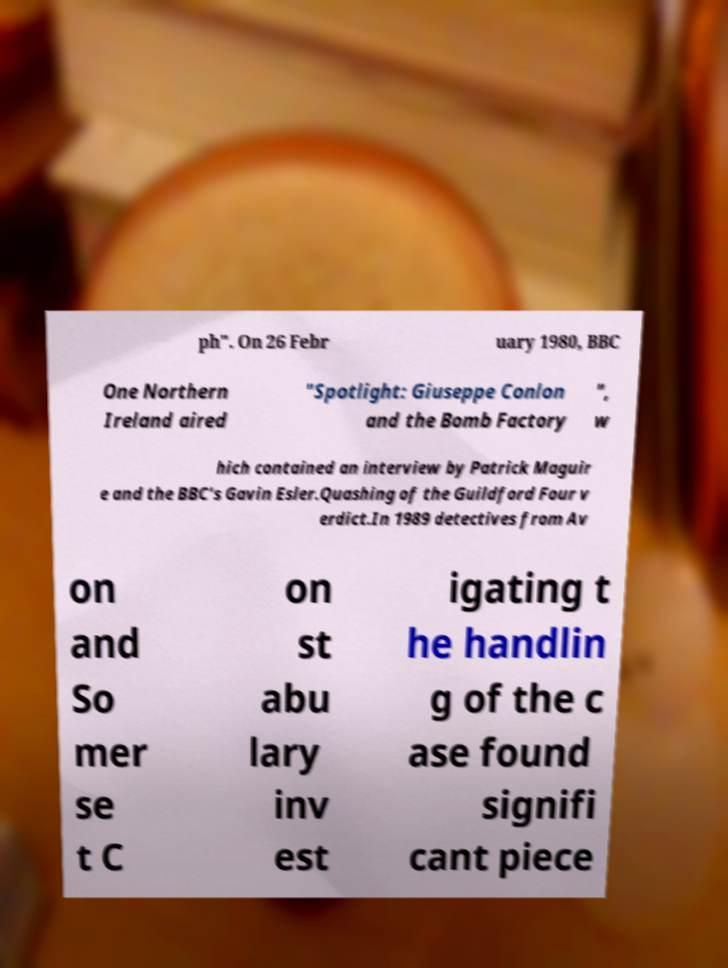Could you extract and type out the text from this image? ph". On 26 Febr uary 1980, BBC One Northern Ireland aired "Spotlight: Giuseppe Conlon and the Bomb Factory ", w hich contained an interview by Patrick Maguir e and the BBC's Gavin Esler.Quashing of the Guildford Four v erdict.In 1989 detectives from Av on and So mer se t C on st abu lary inv est igating t he handlin g of the c ase found signifi cant piece 